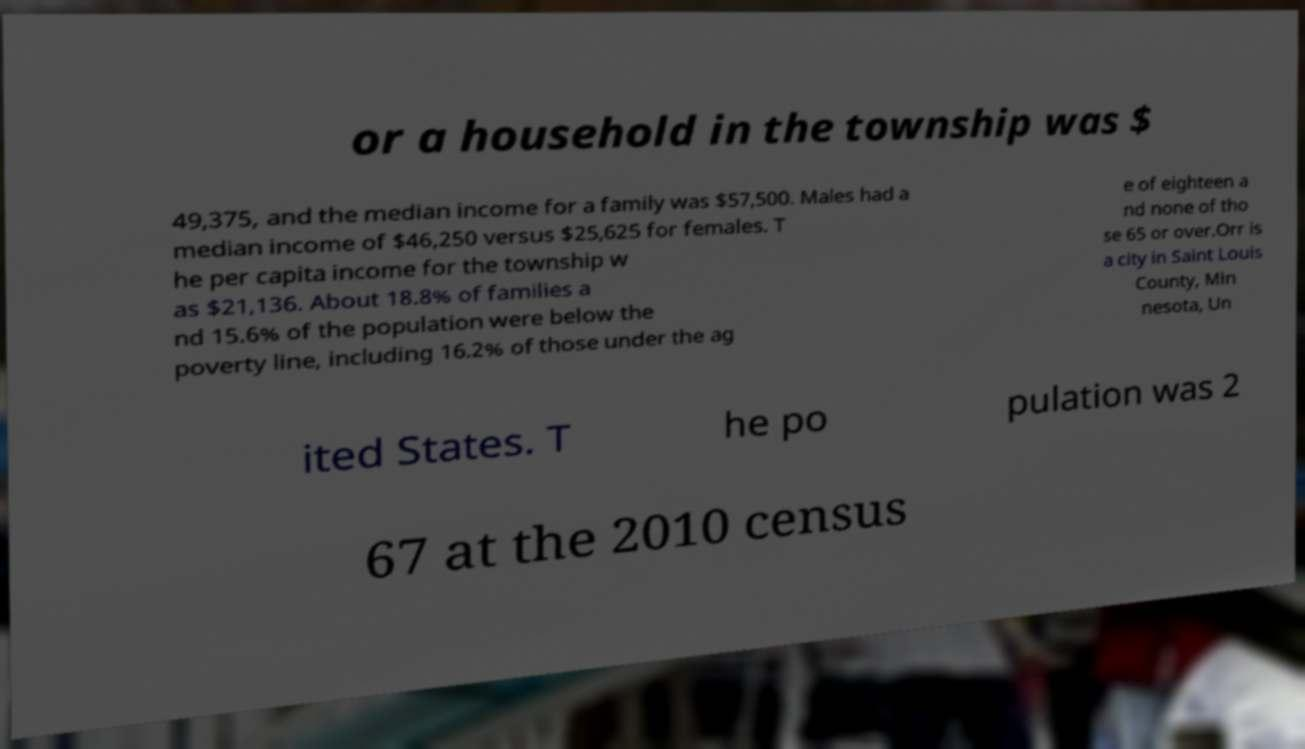Please read and relay the text visible in this image. What does it say? or a household in the township was $ 49,375, and the median income for a family was $57,500. Males had a median income of $46,250 versus $25,625 for females. T he per capita income for the township w as $21,136. About 18.8% of families a nd 15.6% of the population were below the poverty line, including 16.2% of those under the ag e of eighteen a nd none of tho se 65 or over.Orr is a city in Saint Louis County, Min nesota, Un ited States. T he po pulation was 2 67 at the 2010 census 